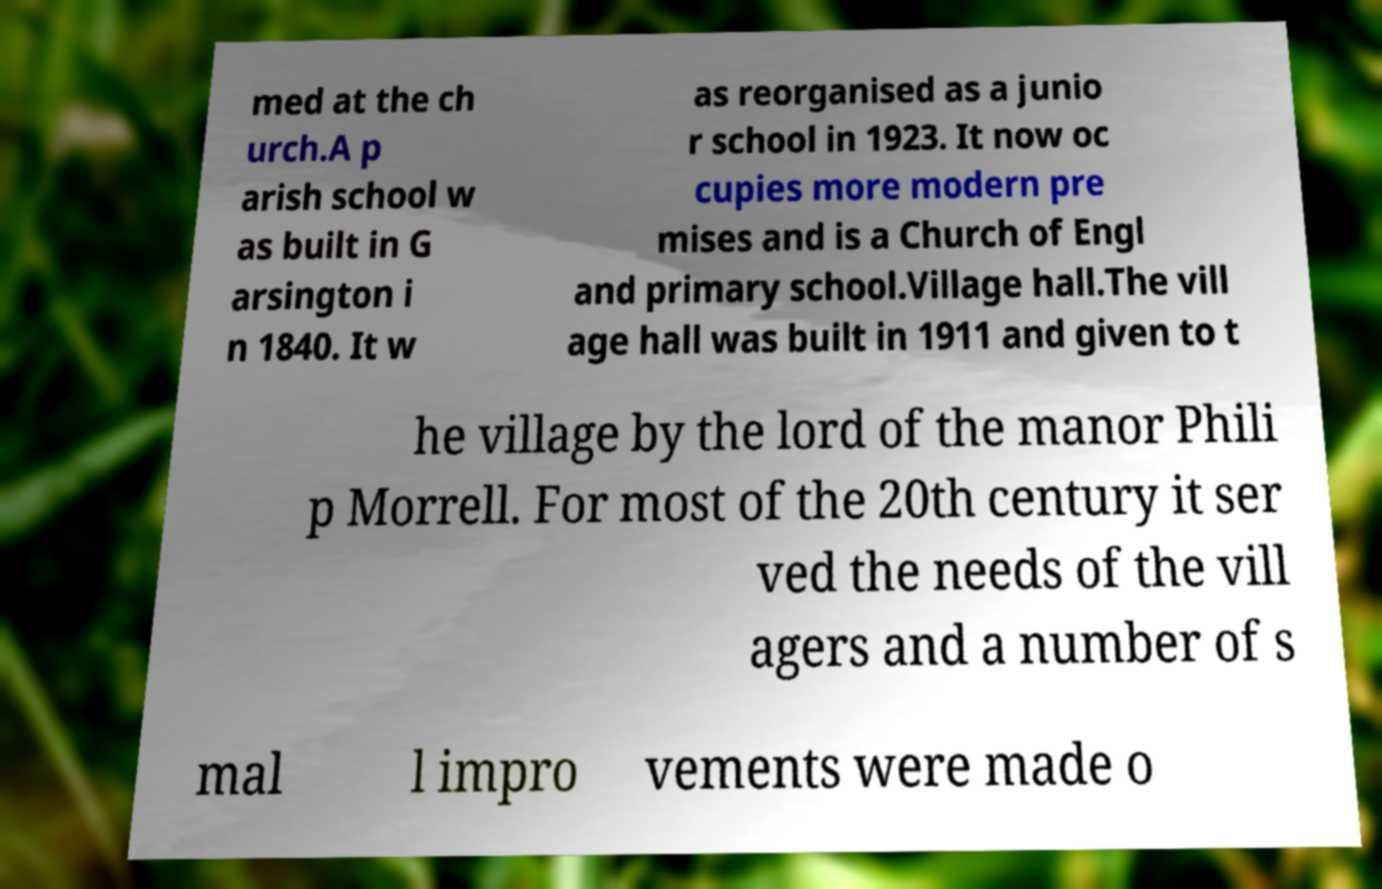Can you read and provide the text displayed in the image?This photo seems to have some interesting text. Can you extract and type it out for me? med at the ch urch.A p arish school w as built in G arsington i n 1840. It w as reorganised as a junio r school in 1923. It now oc cupies more modern pre mises and is a Church of Engl and primary school.Village hall.The vill age hall was built in 1911 and given to t he village by the lord of the manor Phili p Morrell. For most of the 20th century it ser ved the needs of the vill agers and a number of s mal l impro vements were made o 